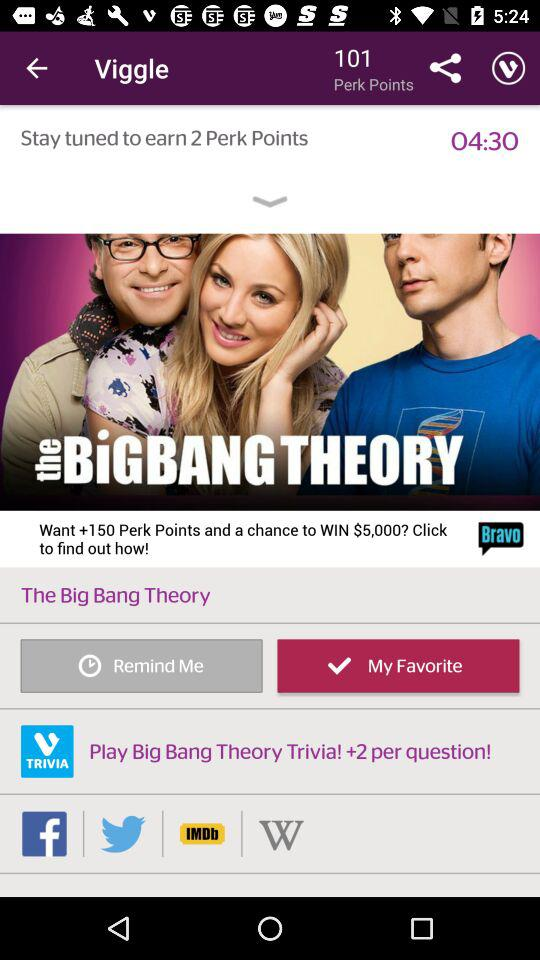How many perk points are there? There are 101 perk points. 